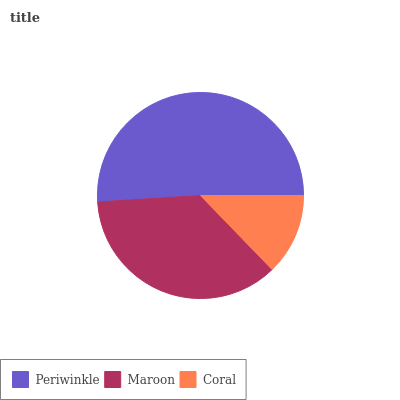Is Coral the minimum?
Answer yes or no. Yes. Is Periwinkle the maximum?
Answer yes or no. Yes. Is Maroon the minimum?
Answer yes or no. No. Is Maroon the maximum?
Answer yes or no. No. Is Periwinkle greater than Maroon?
Answer yes or no. Yes. Is Maroon less than Periwinkle?
Answer yes or no. Yes. Is Maroon greater than Periwinkle?
Answer yes or no. No. Is Periwinkle less than Maroon?
Answer yes or no. No. Is Maroon the high median?
Answer yes or no. Yes. Is Maroon the low median?
Answer yes or no. Yes. Is Coral the high median?
Answer yes or no. No. Is Periwinkle the low median?
Answer yes or no. No. 